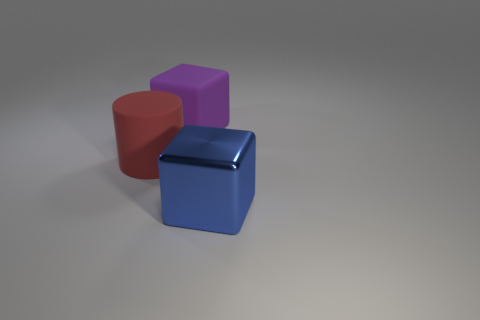Imagine these objects were used in a sorting game for children, how could one organize them? In a sorting game, these objects could be categorized by several attributes: color, shape, or material. Children could sort them into groups of 'red', 'purple', and 'blue', or they could arrange them based on shape into 'cubes' and 'cylinders'. Exploring material, they could differentiate between the 'rubber' objects and the 'metal' one, helping to develop their sensory and cognitive recognition skills. 